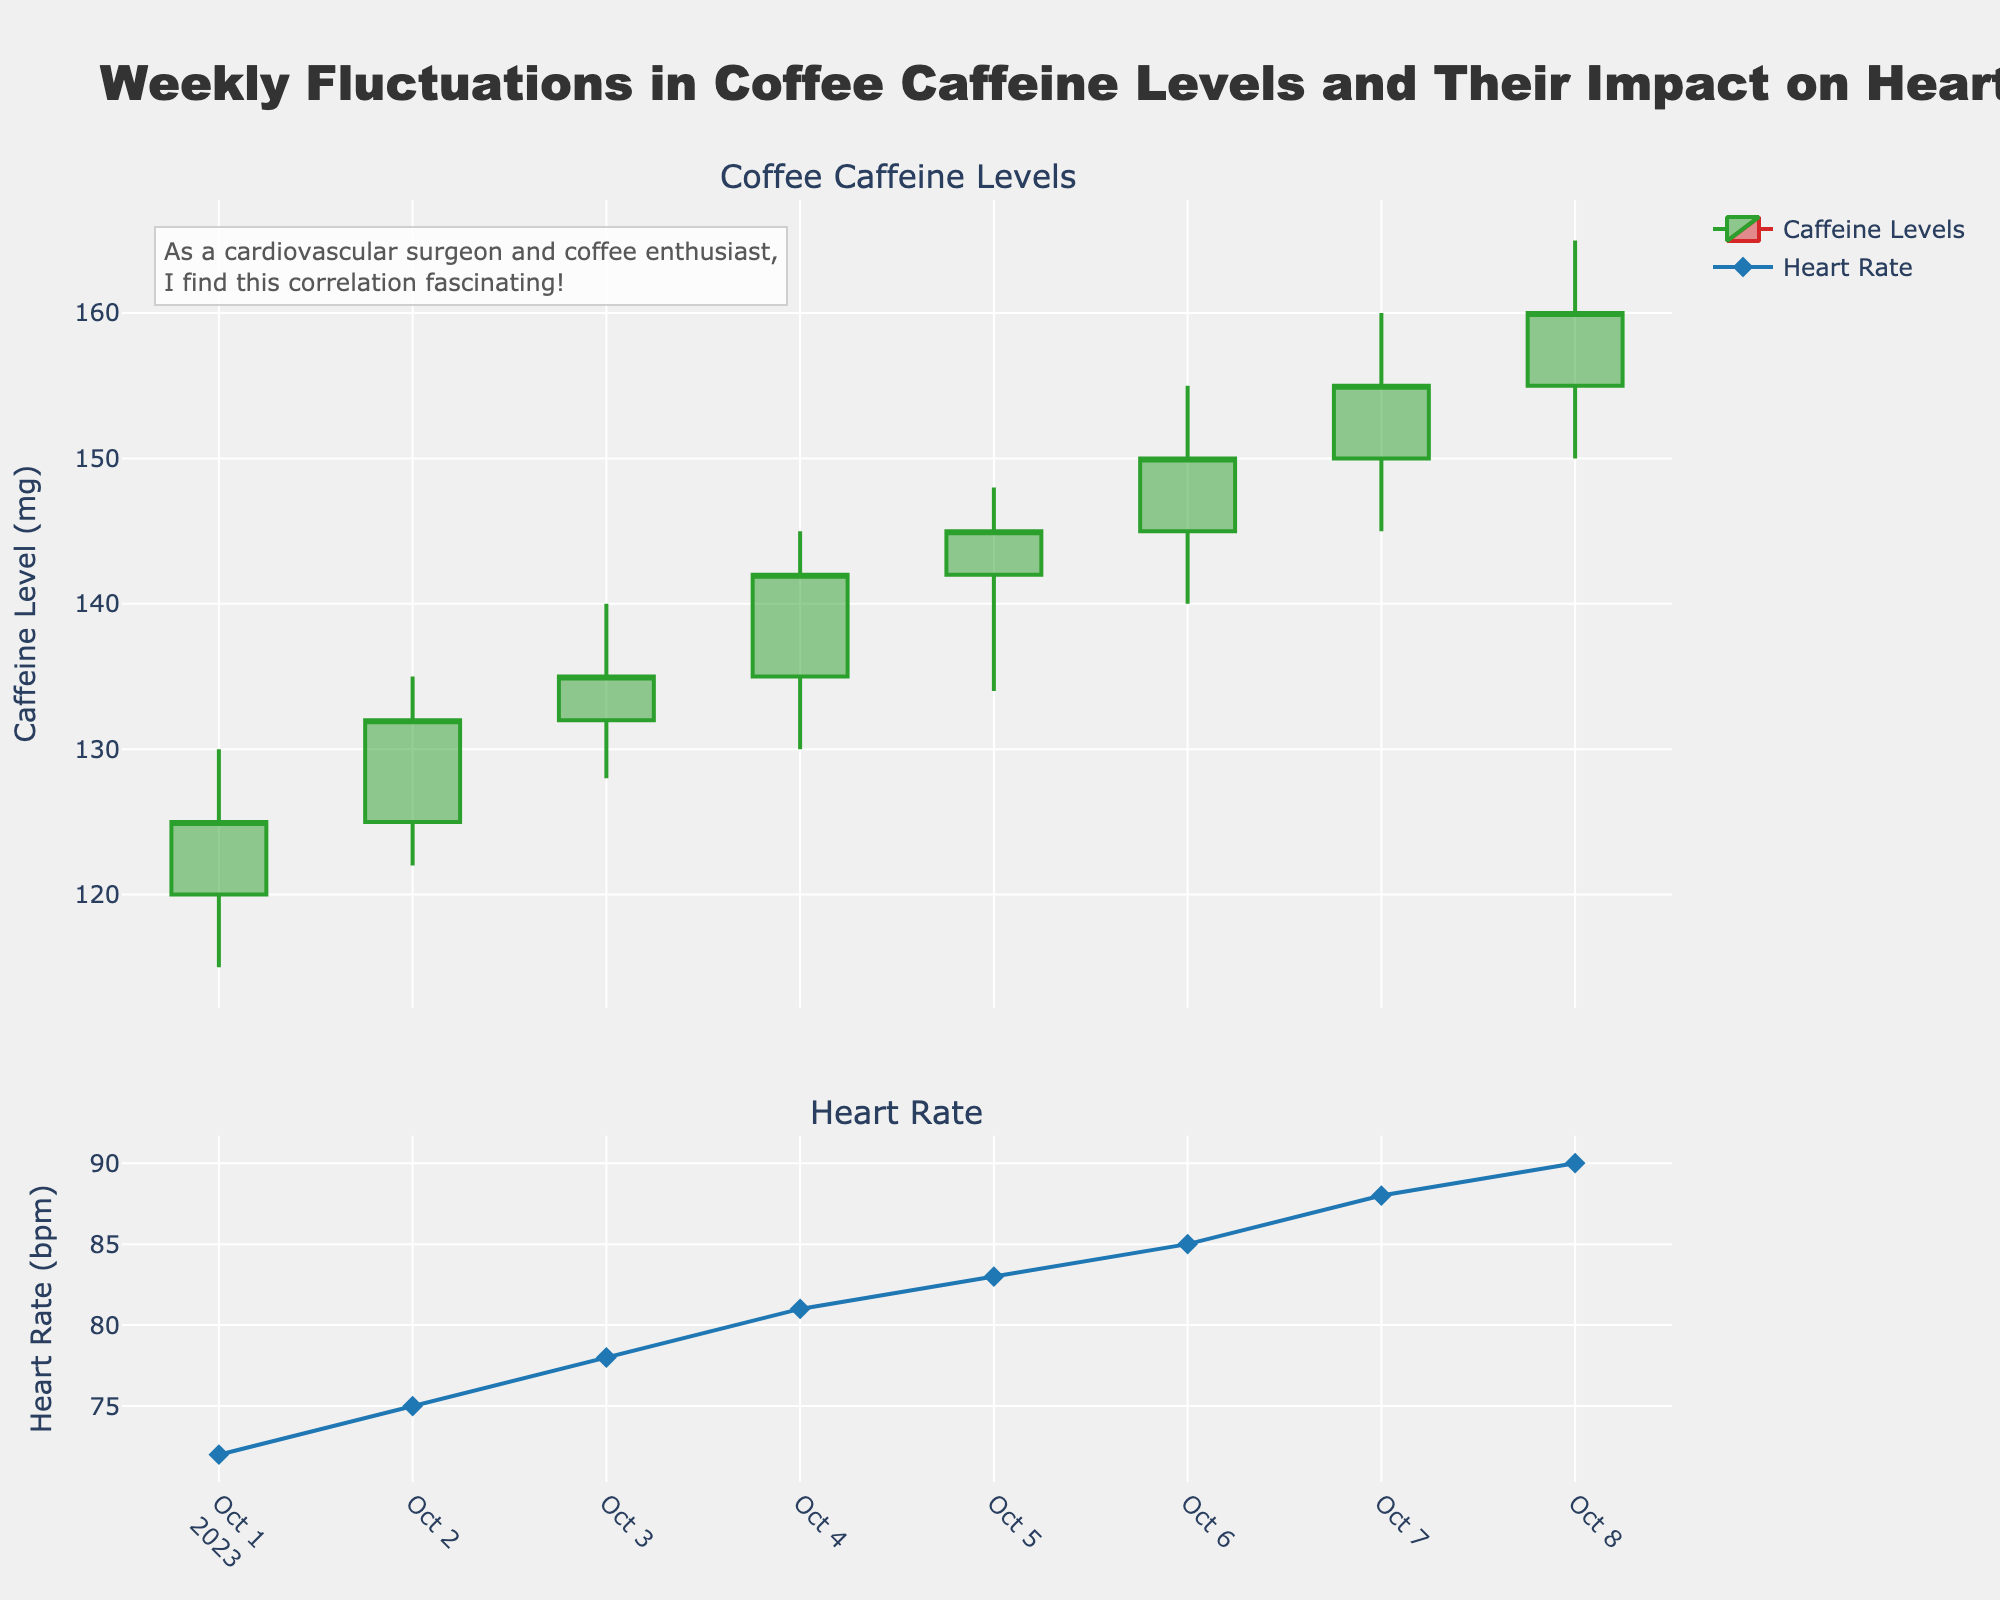What's the title of the figure? The title is clearly displayed at the top of the figure.
Answer: Weekly Fluctuations in Coffee Caffeine Levels and Their Impact on Heart Rate How many data points are there for caffeine levels? Each candlestick represents one data point. There are 8 candlesticks, one for each date from October 1 to October 8.
Answer: 8 What color are the lines representing increasing caffeine levels? The figure uses green for increasing caffeine levels, as indicated in the legend.
Answer: Green Which day shows the highest closing caffeine level? Look at the closing values at the top of the candlesticks. The highest closing level is 160 on October 8.
Answer: October 8 What is the heart rate on October 4? Refer to the second subplot and look at the heart rate value marked by the diamond symbol on October 4.
Answer: 81 bpm How much did the caffeine level increase from October 1 to October 8? Calculate the difference between the closing value on October 8 (160) and the closing value on October 1 (125). 160 - 125 = 35
Answer: 35 mg On which day was the caffeine level most volatile (highest difference between high and low)? Volatility can be seen by looking at the length of the candlesticks. On October 6, the difference between high (155) and low (140) is the largest (15).
Answer: October 6 How does the trend in caffeine levels correlate with the trend in heart rate over the week? Compare the overall upward trend in the candlestick plot (caffeine levels) with the upward trend in the line plot (heart rate). Both trends show an increase over the same time period.
Answer: Both trends are increasing What is the average heart rate over this period? Sum all heart rate values and divide by the number of days: (72 + 75 + 78 + 81 + 83 + 85 + 88 + 90) / 8 = 652 / 8 = 81.5
Answer: 81.5 bpm Which day had the lowest opening caffeine level? Look at the 'Open' values of each day. The lowest opening level, 120, appears on October 1.
Answer: October 1 